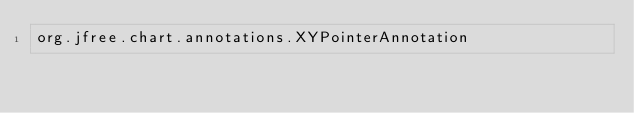<code> <loc_0><loc_0><loc_500><loc_500><_Rust_>org.jfree.chart.annotations.XYPointerAnnotation
</code> 